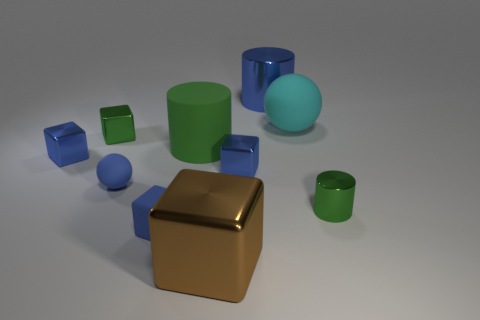Subtract all metallic blocks. How many blocks are left? 1 Subtract all blue cylinders. How many cylinders are left? 2 Subtract all red cubes. How many blue balls are left? 1 Subtract 2 cylinders. How many cylinders are left? 1 Add 6 blue blocks. How many blue blocks are left? 9 Add 5 tiny green cubes. How many tiny green cubes exist? 6 Subtract 0 yellow cubes. How many objects are left? 10 Subtract all balls. How many objects are left? 8 Subtract all purple cylinders. Subtract all yellow blocks. How many cylinders are left? 3 Subtract all small purple cubes. Subtract all big green matte cylinders. How many objects are left? 9 